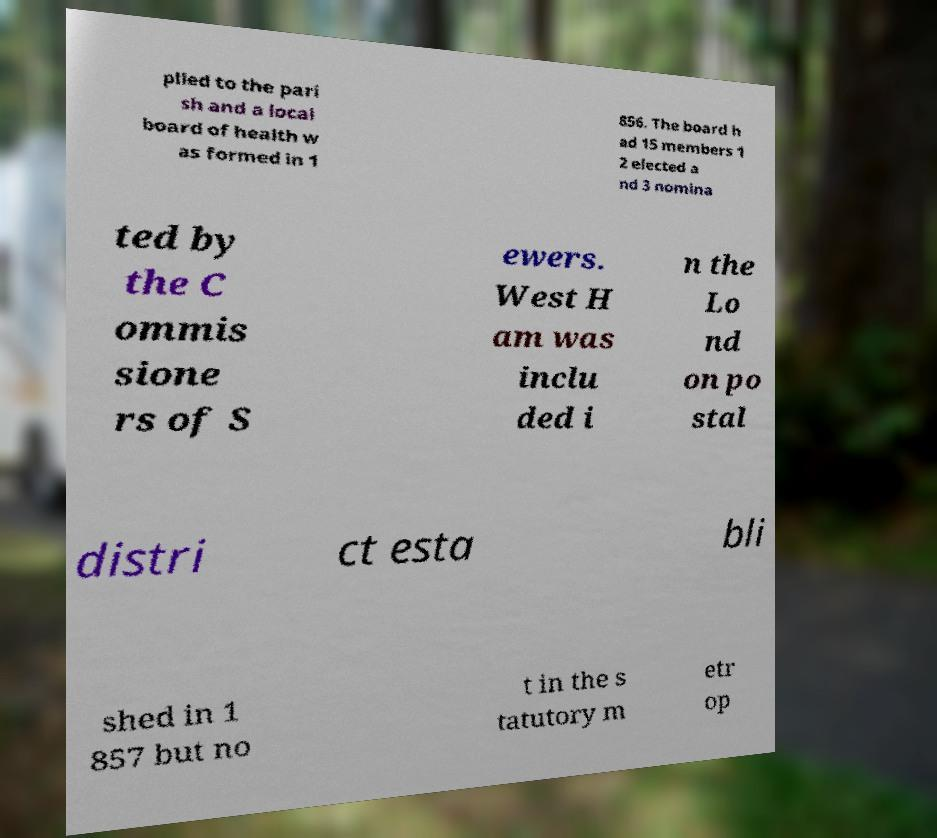There's text embedded in this image that I need extracted. Can you transcribe it verbatim? plied to the pari sh and a local board of health w as formed in 1 856. The board h ad 15 members 1 2 elected a nd 3 nomina ted by the C ommis sione rs of S ewers. West H am was inclu ded i n the Lo nd on po stal distri ct esta bli shed in 1 857 but no t in the s tatutory m etr op 